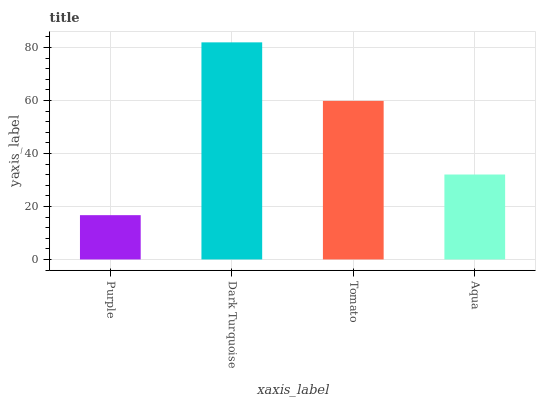Is Purple the minimum?
Answer yes or no. Yes. Is Dark Turquoise the maximum?
Answer yes or no. Yes. Is Tomato the minimum?
Answer yes or no. No. Is Tomato the maximum?
Answer yes or no. No. Is Dark Turquoise greater than Tomato?
Answer yes or no. Yes. Is Tomato less than Dark Turquoise?
Answer yes or no. Yes. Is Tomato greater than Dark Turquoise?
Answer yes or no. No. Is Dark Turquoise less than Tomato?
Answer yes or no. No. Is Tomato the high median?
Answer yes or no. Yes. Is Aqua the low median?
Answer yes or no. Yes. Is Purple the high median?
Answer yes or no. No. Is Tomato the low median?
Answer yes or no. No. 